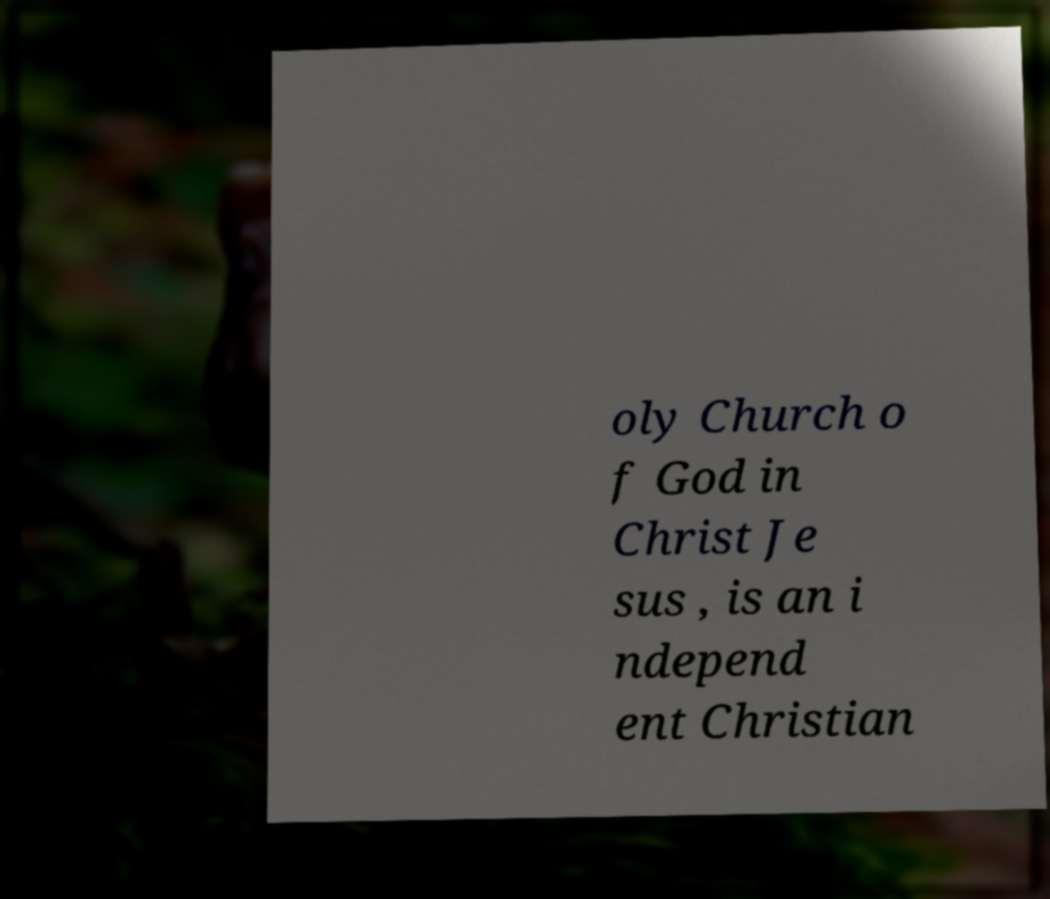What messages or text are displayed in this image? I need them in a readable, typed format. oly Church o f God in Christ Je sus , is an i ndepend ent Christian 